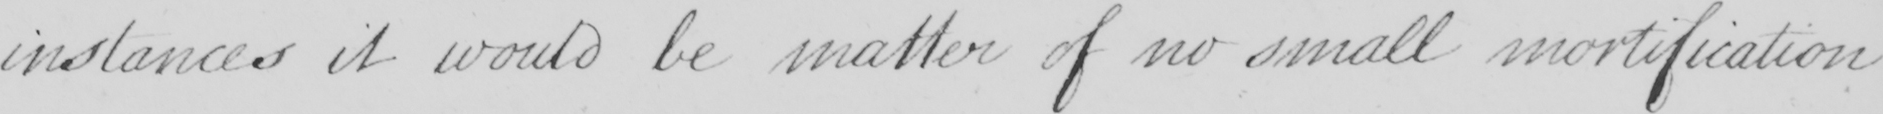Transcribe the text shown in this historical manuscript line. instances it would be matter of no small mortification 